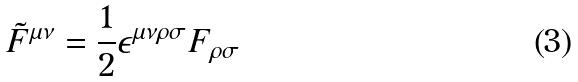<formula> <loc_0><loc_0><loc_500><loc_500>\tilde { F } ^ { \mu \nu } = \frac { 1 } { 2 } \epsilon ^ { \mu \nu \rho \sigma } F _ { \rho \sigma }</formula> 